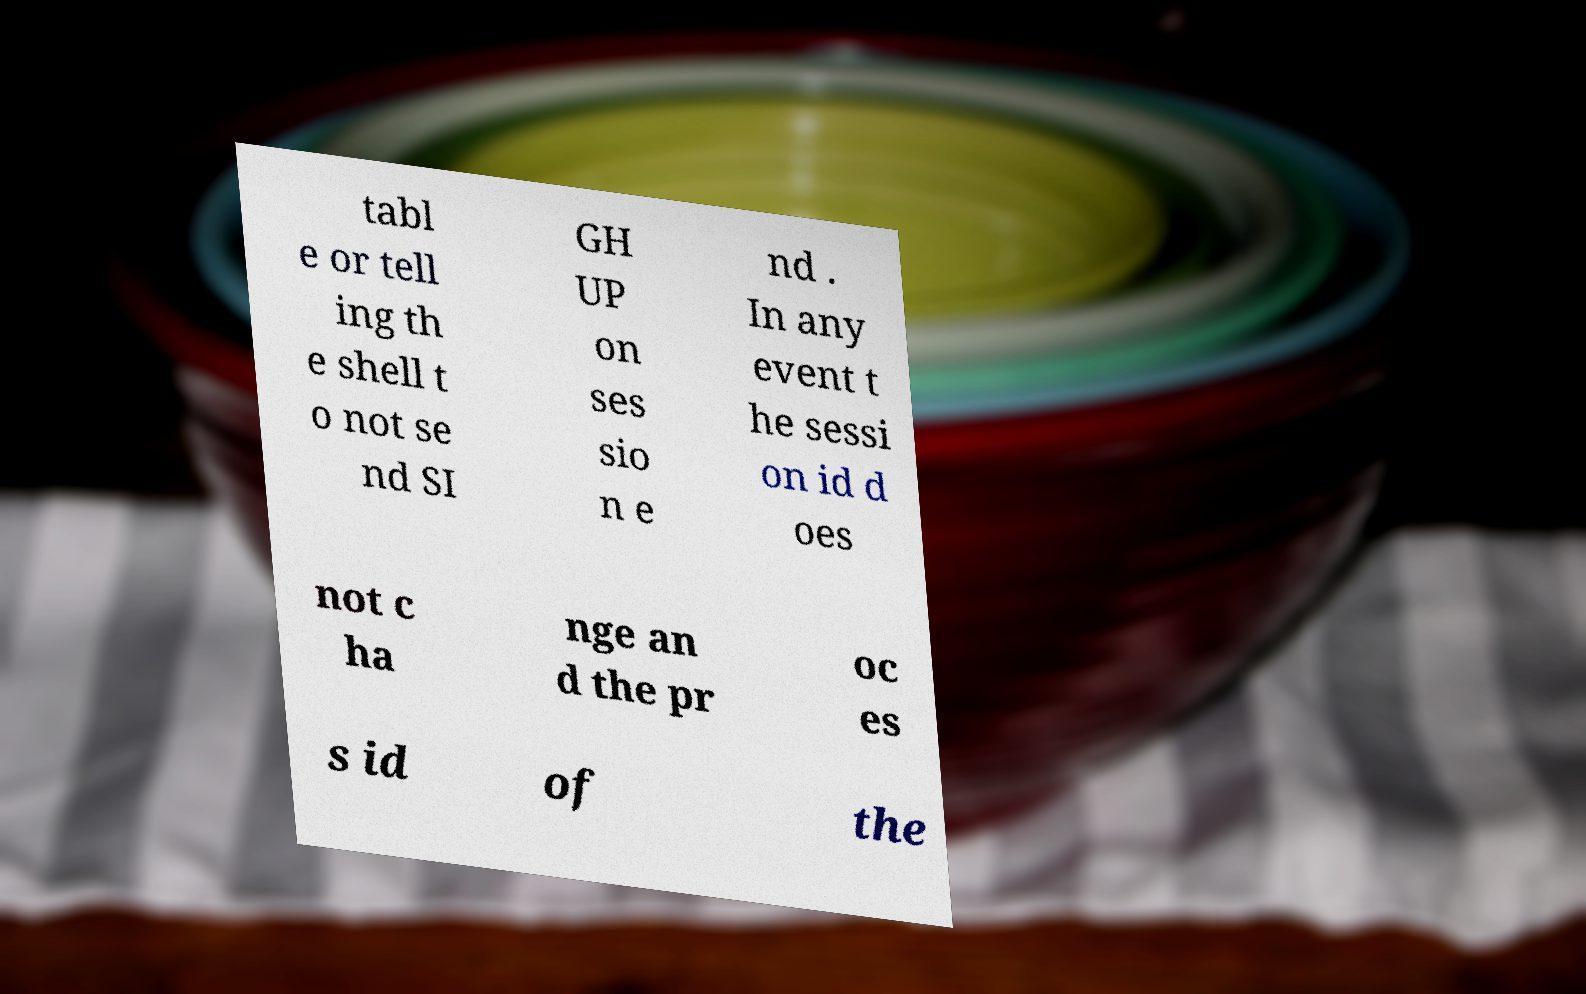Can you accurately transcribe the text from the provided image for me? tabl e or tell ing th e shell t o not se nd SI GH UP on ses sio n e nd . In any event t he sessi on id d oes not c ha nge an d the pr oc es s id of the 